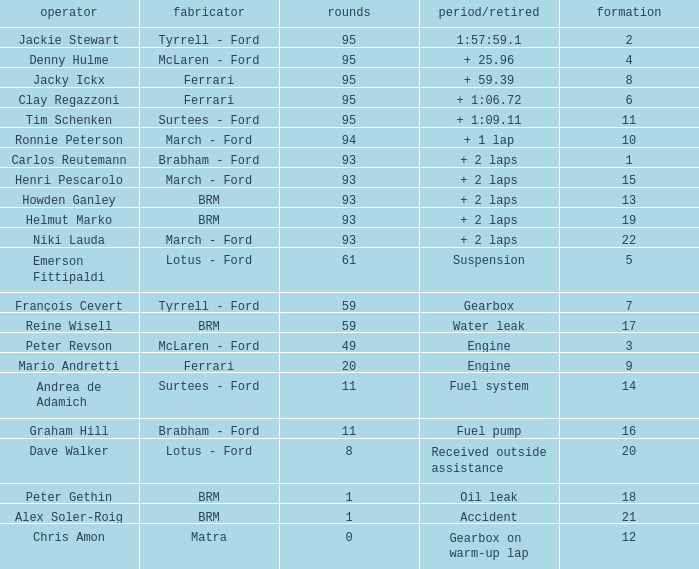What is the largest number of laps with a Grid larger than 14, a Time/Retired of + 2 laps, and a Driver of helmut marko? 93.0. 